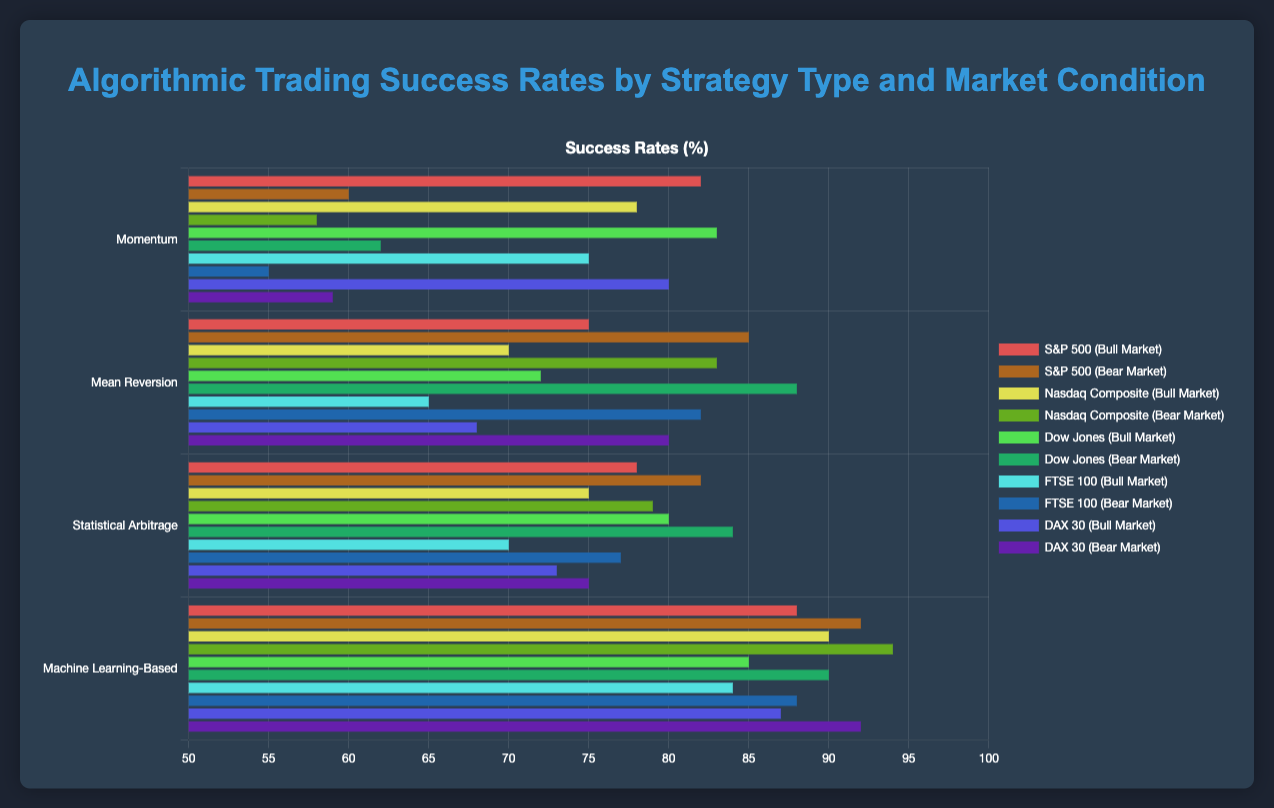What's the best-performing strategy in a bull market? By observing the highest bar within the bull market section, the Machine Learning-Based strategy shows the highest success rate across different indexes, reaching a maximum value among all strategies.
Answer: Machine Learning-Based Which index performs better in bear markets with the Momentum strategy: S&P 500 or Nasdaq Composite? Comparing the bars corresponding to S&P 500 and Nasdaq Composite under the Momentum strategy in bear markets, S&P 500 has a success rate of 60 while Nasdaq Composite has a success rate of 58.
Answer: S&P 500 What's the average success rate of the Machine Learning-Based strategy across all market conditions and indices? For the Machine Learning-Based strategy, sum the success rates across all indices and market conditions: (88+90+85+84+87) for bull and (92+94+90+88+92) for bear. Calculate the average of these 10 values: (88+90+85+84+87+92+94+90+88+92)/10 = 89.
Answer: 89 Which bar is the tallest among the bear market sections? Visually determine the tallest bar within the bear market sections. This corresponds to the Nasdaq Composite index under the Machine Learning-Based strategy with a success rate of 94.
Answer: Nasdaq Composite (Machine Learning-Based) Compare the success rates of Mean Reversion strategy in bull markets vs. bear markets. Which condition shows higher effectiveness? In bull markets, average success rate = (75+70+72+65+68)/5 = 70. In bear markets, average success rate = (85+83+88+82+80)/5 = 83. The bear market success rate is higher.
Answer: Bear Market How much higher is the Dow Jones index's success rate with the Statistical Arbitrage strategy in bear markets compared to bull markets? Dow Jones (Statistical Arbitrage): Bear market success rate = 84, Bull market success rate = 80. Difference = 84 - 80 = 4.
Answer: 4 Which strategy has the least variation in success rates across different market conditions for the FTSE 100 index? Compare FTSE 100 success rate differences between bull and bear markets for each strategy. The differences are: Momentum: 20 (75-55), Mean Reversion: 17 (82-65), Statistical Arbitrage: 7 (77-70), Machine Learning-Based: 4 (88-84). The least variation is in the Machine Learning-Based strategy.
Answer: Machine Learning-Based What's the total success rate across all indices for the Momentum strategy in a bear market? Sum the success rates for all indices under the Momentum strategy in a bear market: S&P 500 (60) + Nasdaq Composite (58) + Dow Jones (62) + FTSE 100 (55) + DAX 30 (59) = 294.
Answer: 294 Which index has the most consistent success rate regardless of market condition for the Mean Reversion strategy? By comparing the success rates in both market conditions for each index under the Mean Reversion strategy: S&P 500 (75 in bull, 85 in bear), Nasdaq Composite (70 in bull, 83 in bear), Dow Jones (72 in bull, 88 in bear), FTSE 100 (65 in bull, 82 in bear), DAX 30 (68 in bull, 80 in bear). FTSE 100 has the smallest difference of 17.
Answer: FTSE 100 